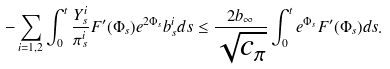<formula> <loc_0><loc_0><loc_500><loc_500>- \sum _ { i = 1 , 2 } \int _ { 0 } ^ { t } \frac { Y ^ { i } _ { s } } { \pi ^ { i } _ { s } } F ^ { \prime } ( \Phi _ { s } ) e ^ { 2 \Phi _ { s } } b ^ { i } _ { s } d s \leq \frac { 2 b _ { \infty } } { \sqrt { c _ { \pi } } } \int _ { 0 } ^ { t } e ^ { \Phi _ { s } } F ^ { \prime } ( \Phi _ { s } ) d s .</formula> 